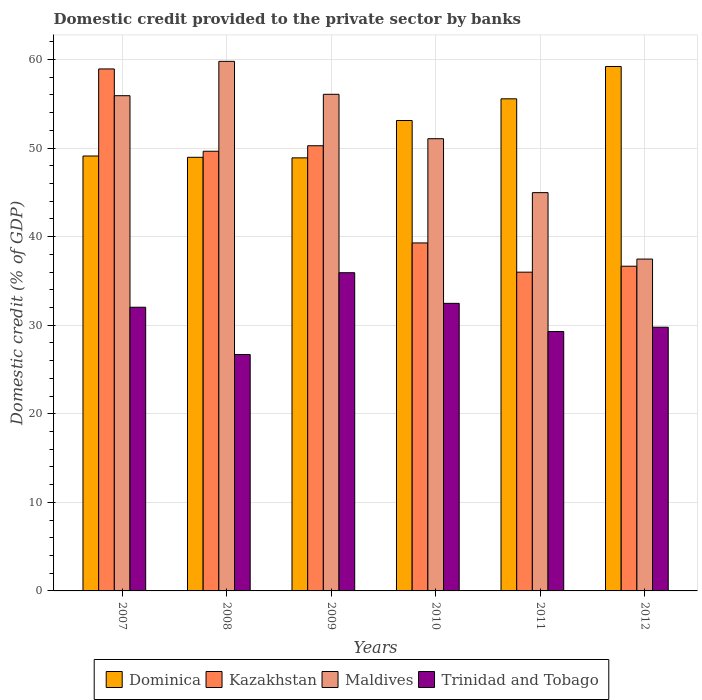How many different coloured bars are there?
Make the answer very short. 4. How many groups of bars are there?
Keep it short and to the point. 6. How many bars are there on the 4th tick from the right?
Your answer should be very brief. 4. What is the domestic credit provided to the private sector by banks in Maldives in 2010?
Provide a succinct answer. 51.06. Across all years, what is the maximum domestic credit provided to the private sector by banks in Trinidad and Tobago?
Make the answer very short. 35.93. Across all years, what is the minimum domestic credit provided to the private sector by banks in Maldives?
Keep it short and to the point. 37.47. What is the total domestic credit provided to the private sector by banks in Dominica in the graph?
Your response must be concise. 314.86. What is the difference between the domestic credit provided to the private sector by banks in Trinidad and Tobago in 2011 and that in 2012?
Offer a very short reply. -0.49. What is the difference between the domestic credit provided to the private sector by banks in Dominica in 2011 and the domestic credit provided to the private sector by banks in Trinidad and Tobago in 2012?
Give a very brief answer. 25.79. What is the average domestic credit provided to the private sector by banks in Kazakhstan per year?
Give a very brief answer. 45.13. In the year 2011, what is the difference between the domestic credit provided to the private sector by banks in Trinidad and Tobago and domestic credit provided to the private sector by banks in Maldives?
Provide a succinct answer. -15.68. In how many years, is the domestic credit provided to the private sector by banks in Trinidad and Tobago greater than 4 %?
Provide a succinct answer. 6. What is the ratio of the domestic credit provided to the private sector by banks in Kazakhstan in 2007 to that in 2008?
Your answer should be very brief. 1.19. Is the domestic credit provided to the private sector by banks in Dominica in 2010 less than that in 2012?
Your response must be concise. Yes. What is the difference between the highest and the second highest domestic credit provided to the private sector by banks in Trinidad and Tobago?
Keep it short and to the point. 3.46. What is the difference between the highest and the lowest domestic credit provided to the private sector by banks in Maldives?
Keep it short and to the point. 22.32. Is the sum of the domestic credit provided to the private sector by banks in Maldives in 2011 and 2012 greater than the maximum domestic credit provided to the private sector by banks in Kazakhstan across all years?
Keep it short and to the point. Yes. What does the 4th bar from the left in 2009 represents?
Ensure brevity in your answer.  Trinidad and Tobago. What does the 1st bar from the right in 2008 represents?
Your answer should be very brief. Trinidad and Tobago. How many bars are there?
Provide a succinct answer. 24. Are the values on the major ticks of Y-axis written in scientific E-notation?
Give a very brief answer. No. Where does the legend appear in the graph?
Ensure brevity in your answer.  Bottom center. How are the legend labels stacked?
Your response must be concise. Horizontal. What is the title of the graph?
Make the answer very short. Domestic credit provided to the private sector by banks. Does "Colombia" appear as one of the legend labels in the graph?
Your answer should be compact. No. What is the label or title of the X-axis?
Provide a succinct answer. Years. What is the label or title of the Y-axis?
Offer a very short reply. Domestic credit (% of GDP). What is the Domestic credit (% of GDP) in Dominica in 2007?
Ensure brevity in your answer.  49.11. What is the Domestic credit (% of GDP) in Kazakhstan in 2007?
Make the answer very short. 58.94. What is the Domestic credit (% of GDP) in Maldives in 2007?
Ensure brevity in your answer.  55.92. What is the Domestic credit (% of GDP) in Trinidad and Tobago in 2007?
Your answer should be very brief. 32.03. What is the Domestic credit (% of GDP) of Dominica in 2008?
Your answer should be very brief. 48.96. What is the Domestic credit (% of GDP) of Kazakhstan in 2008?
Offer a terse response. 49.64. What is the Domestic credit (% of GDP) in Maldives in 2008?
Your response must be concise. 59.8. What is the Domestic credit (% of GDP) of Trinidad and Tobago in 2008?
Offer a very short reply. 26.69. What is the Domestic credit (% of GDP) of Dominica in 2009?
Offer a terse response. 48.9. What is the Domestic credit (% of GDP) in Kazakhstan in 2009?
Provide a succinct answer. 50.27. What is the Domestic credit (% of GDP) of Maldives in 2009?
Keep it short and to the point. 56.07. What is the Domestic credit (% of GDP) in Trinidad and Tobago in 2009?
Offer a terse response. 35.93. What is the Domestic credit (% of GDP) in Dominica in 2010?
Your answer should be compact. 53.12. What is the Domestic credit (% of GDP) in Kazakhstan in 2010?
Provide a succinct answer. 39.29. What is the Domestic credit (% of GDP) of Maldives in 2010?
Provide a succinct answer. 51.06. What is the Domestic credit (% of GDP) of Trinidad and Tobago in 2010?
Give a very brief answer. 32.47. What is the Domestic credit (% of GDP) of Dominica in 2011?
Your response must be concise. 55.56. What is the Domestic credit (% of GDP) in Kazakhstan in 2011?
Ensure brevity in your answer.  35.99. What is the Domestic credit (% of GDP) of Maldives in 2011?
Your answer should be compact. 44.97. What is the Domestic credit (% of GDP) of Trinidad and Tobago in 2011?
Your response must be concise. 29.29. What is the Domestic credit (% of GDP) of Dominica in 2012?
Offer a very short reply. 59.21. What is the Domestic credit (% of GDP) of Kazakhstan in 2012?
Offer a terse response. 36.66. What is the Domestic credit (% of GDP) of Maldives in 2012?
Make the answer very short. 37.47. What is the Domestic credit (% of GDP) of Trinidad and Tobago in 2012?
Make the answer very short. 29.78. Across all years, what is the maximum Domestic credit (% of GDP) in Dominica?
Provide a short and direct response. 59.21. Across all years, what is the maximum Domestic credit (% of GDP) of Kazakhstan?
Make the answer very short. 58.94. Across all years, what is the maximum Domestic credit (% of GDP) of Maldives?
Your answer should be compact. 59.8. Across all years, what is the maximum Domestic credit (% of GDP) in Trinidad and Tobago?
Keep it short and to the point. 35.93. Across all years, what is the minimum Domestic credit (% of GDP) of Dominica?
Provide a succinct answer. 48.9. Across all years, what is the minimum Domestic credit (% of GDP) of Kazakhstan?
Give a very brief answer. 35.99. Across all years, what is the minimum Domestic credit (% of GDP) in Maldives?
Ensure brevity in your answer.  37.47. Across all years, what is the minimum Domestic credit (% of GDP) in Trinidad and Tobago?
Your answer should be compact. 26.69. What is the total Domestic credit (% of GDP) in Dominica in the graph?
Offer a terse response. 314.86. What is the total Domestic credit (% of GDP) of Kazakhstan in the graph?
Your response must be concise. 270.8. What is the total Domestic credit (% of GDP) in Maldives in the graph?
Your response must be concise. 305.29. What is the total Domestic credit (% of GDP) of Trinidad and Tobago in the graph?
Make the answer very short. 186.19. What is the difference between the Domestic credit (% of GDP) in Dominica in 2007 and that in 2008?
Provide a succinct answer. 0.15. What is the difference between the Domestic credit (% of GDP) of Kazakhstan in 2007 and that in 2008?
Offer a very short reply. 9.29. What is the difference between the Domestic credit (% of GDP) in Maldives in 2007 and that in 2008?
Make the answer very short. -3.88. What is the difference between the Domestic credit (% of GDP) of Trinidad and Tobago in 2007 and that in 2008?
Offer a very short reply. 5.34. What is the difference between the Domestic credit (% of GDP) of Dominica in 2007 and that in 2009?
Your answer should be compact. 0.21. What is the difference between the Domestic credit (% of GDP) of Kazakhstan in 2007 and that in 2009?
Offer a terse response. 8.67. What is the difference between the Domestic credit (% of GDP) in Maldives in 2007 and that in 2009?
Offer a very short reply. -0.16. What is the difference between the Domestic credit (% of GDP) in Trinidad and Tobago in 2007 and that in 2009?
Give a very brief answer. -3.9. What is the difference between the Domestic credit (% of GDP) of Dominica in 2007 and that in 2010?
Ensure brevity in your answer.  -4.01. What is the difference between the Domestic credit (% of GDP) in Kazakhstan in 2007 and that in 2010?
Your response must be concise. 19.65. What is the difference between the Domestic credit (% of GDP) in Maldives in 2007 and that in 2010?
Your answer should be compact. 4.86. What is the difference between the Domestic credit (% of GDP) of Trinidad and Tobago in 2007 and that in 2010?
Offer a terse response. -0.44. What is the difference between the Domestic credit (% of GDP) in Dominica in 2007 and that in 2011?
Offer a terse response. -6.46. What is the difference between the Domestic credit (% of GDP) of Kazakhstan in 2007 and that in 2011?
Keep it short and to the point. 22.95. What is the difference between the Domestic credit (% of GDP) in Maldives in 2007 and that in 2011?
Provide a short and direct response. 10.95. What is the difference between the Domestic credit (% of GDP) in Trinidad and Tobago in 2007 and that in 2011?
Keep it short and to the point. 2.74. What is the difference between the Domestic credit (% of GDP) of Dominica in 2007 and that in 2012?
Offer a terse response. -10.11. What is the difference between the Domestic credit (% of GDP) of Kazakhstan in 2007 and that in 2012?
Your answer should be very brief. 22.27. What is the difference between the Domestic credit (% of GDP) in Maldives in 2007 and that in 2012?
Your response must be concise. 18.45. What is the difference between the Domestic credit (% of GDP) of Trinidad and Tobago in 2007 and that in 2012?
Ensure brevity in your answer.  2.26. What is the difference between the Domestic credit (% of GDP) in Dominica in 2008 and that in 2009?
Your answer should be very brief. 0.06. What is the difference between the Domestic credit (% of GDP) of Kazakhstan in 2008 and that in 2009?
Ensure brevity in your answer.  -0.62. What is the difference between the Domestic credit (% of GDP) of Maldives in 2008 and that in 2009?
Provide a succinct answer. 3.72. What is the difference between the Domestic credit (% of GDP) of Trinidad and Tobago in 2008 and that in 2009?
Offer a very short reply. -9.24. What is the difference between the Domestic credit (% of GDP) of Dominica in 2008 and that in 2010?
Your answer should be very brief. -4.15. What is the difference between the Domestic credit (% of GDP) of Kazakhstan in 2008 and that in 2010?
Provide a short and direct response. 10.35. What is the difference between the Domestic credit (% of GDP) in Maldives in 2008 and that in 2010?
Offer a terse response. 8.73. What is the difference between the Domestic credit (% of GDP) in Trinidad and Tobago in 2008 and that in 2010?
Your response must be concise. -5.78. What is the difference between the Domestic credit (% of GDP) of Dominica in 2008 and that in 2011?
Keep it short and to the point. -6.6. What is the difference between the Domestic credit (% of GDP) in Kazakhstan in 2008 and that in 2011?
Keep it short and to the point. 13.65. What is the difference between the Domestic credit (% of GDP) in Maldives in 2008 and that in 2011?
Your answer should be compact. 14.82. What is the difference between the Domestic credit (% of GDP) of Trinidad and Tobago in 2008 and that in 2011?
Give a very brief answer. -2.6. What is the difference between the Domestic credit (% of GDP) of Dominica in 2008 and that in 2012?
Provide a succinct answer. -10.25. What is the difference between the Domestic credit (% of GDP) in Kazakhstan in 2008 and that in 2012?
Provide a succinct answer. 12.98. What is the difference between the Domestic credit (% of GDP) in Maldives in 2008 and that in 2012?
Your answer should be very brief. 22.32. What is the difference between the Domestic credit (% of GDP) of Trinidad and Tobago in 2008 and that in 2012?
Provide a succinct answer. -3.08. What is the difference between the Domestic credit (% of GDP) of Dominica in 2009 and that in 2010?
Provide a short and direct response. -4.22. What is the difference between the Domestic credit (% of GDP) of Kazakhstan in 2009 and that in 2010?
Your answer should be very brief. 10.97. What is the difference between the Domestic credit (% of GDP) in Maldives in 2009 and that in 2010?
Offer a very short reply. 5.01. What is the difference between the Domestic credit (% of GDP) in Trinidad and Tobago in 2009 and that in 2010?
Offer a very short reply. 3.46. What is the difference between the Domestic credit (% of GDP) in Dominica in 2009 and that in 2011?
Provide a succinct answer. -6.67. What is the difference between the Domestic credit (% of GDP) in Kazakhstan in 2009 and that in 2011?
Your response must be concise. 14.27. What is the difference between the Domestic credit (% of GDP) in Maldives in 2009 and that in 2011?
Keep it short and to the point. 11.1. What is the difference between the Domestic credit (% of GDP) in Trinidad and Tobago in 2009 and that in 2011?
Offer a terse response. 6.64. What is the difference between the Domestic credit (% of GDP) of Dominica in 2009 and that in 2012?
Give a very brief answer. -10.32. What is the difference between the Domestic credit (% of GDP) of Kazakhstan in 2009 and that in 2012?
Ensure brevity in your answer.  13.6. What is the difference between the Domestic credit (% of GDP) of Maldives in 2009 and that in 2012?
Offer a very short reply. 18.6. What is the difference between the Domestic credit (% of GDP) in Trinidad and Tobago in 2009 and that in 2012?
Offer a very short reply. 6.15. What is the difference between the Domestic credit (% of GDP) in Dominica in 2010 and that in 2011?
Your answer should be compact. -2.45. What is the difference between the Domestic credit (% of GDP) in Kazakhstan in 2010 and that in 2011?
Make the answer very short. 3.3. What is the difference between the Domestic credit (% of GDP) in Maldives in 2010 and that in 2011?
Offer a very short reply. 6.09. What is the difference between the Domestic credit (% of GDP) in Trinidad and Tobago in 2010 and that in 2011?
Offer a very short reply. 3.18. What is the difference between the Domestic credit (% of GDP) of Dominica in 2010 and that in 2012?
Provide a short and direct response. -6.1. What is the difference between the Domestic credit (% of GDP) of Kazakhstan in 2010 and that in 2012?
Offer a very short reply. 2.63. What is the difference between the Domestic credit (% of GDP) of Maldives in 2010 and that in 2012?
Your response must be concise. 13.59. What is the difference between the Domestic credit (% of GDP) in Trinidad and Tobago in 2010 and that in 2012?
Keep it short and to the point. 2.7. What is the difference between the Domestic credit (% of GDP) of Dominica in 2011 and that in 2012?
Give a very brief answer. -3.65. What is the difference between the Domestic credit (% of GDP) in Kazakhstan in 2011 and that in 2012?
Keep it short and to the point. -0.67. What is the difference between the Domestic credit (% of GDP) of Maldives in 2011 and that in 2012?
Offer a very short reply. 7.5. What is the difference between the Domestic credit (% of GDP) in Trinidad and Tobago in 2011 and that in 2012?
Provide a succinct answer. -0.49. What is the difference between the Domestic credit (% of GDP) of Dominica in 2007 and the Domestic credit (% of GDP) of Kazakhstan in 2008?
Your response must be concise. -0.54. What is the difference between the Domestic credit (% of GDP) in Dominica in 2007 and the Domestic credit (% of GDP) in Maldives in 2008?
Make the answer very short. -10.69. What is the difference between the Domestic credit (% of GDP) in Dominica in 2007 and the Domestic credit (% of GDP) in Trinidad and Tobago in 2008?
Make the answer very short. 22.42. What is the difference between the Domestic credit (% of GDP) in Kazakhstan in 2007 and the Domestic credit (% of GDP) in Maldives in 2008?
Offer a terse response. -0.86. What is the difference between the Domestic credit (% of GDP) in Kazakhstan in 2007 and the Domestic credit (% of GDP) in Trinidad and Tobago in 2008?
Provide a short and direct response. 32.25. What is the difference between the Domestic credit (% of GDP) of Maldives in 2007 and the Domestic credit (% of GDP) of Trinidad and Tobago in 2008?
Your answer should be very brief. 29.22. What is the difference between the Domestic credit (% of GDP) in Dominica in 2007 and the Domestic credit (% of GDP) in Kazakhstan in 2009?
Make the answer very short. -1.16. What is the difference between the Domestic credit (% of GDP) of Dominica in 2007 and the Domestic credit (% of GDP) of Maldives in 2009?
Give a very brief answer. -6.97. What is the difference between the Domestic credit (% of GDP) in Dominica in 2007 and the Domestic credit (% of GDP) in Trinidad and Tobago in 2009?
Your response must be concise. 13.18. What is the difference between the Domestic credit (% of GDP) in Kazakhstan in 2007 and the Domestic credit (% of GDP) in Maldives in 2009?
Your response must be concise. 2.86. What is the difference between the Domestic credit (% of GDP) of Kazakhstan in 2007 and the Domestic credit (% of GDP) of Trinidad and Tobago in 2009?
Keep it short and to the point. 23.01. What is the difference between the Domestic credit (% of GDP) in Maldives in 2007 and the Domestic credit (% of GDP) in Trinidad and Tobago in 2009?
Provide a succinct answer. 19.99. What is the difference between the Domestic credit (% of GDP) in Dominica in 2007 and the Domestic credit (% of GDP) in Kazakhstan in 2010?
Ensure brevity in your answer.  9.82. What is the difference between the Domestic credit (% of GDP) of Dominica in 2007 and the Domestic credit (% of GDP) of Maldives in 2010?
Keep it short and to the point. -1.95. What is the difference between the Domestic credit (% of GDP) in Dominica in 2007 and the Domestic credit (% of GDP) in Trinidad and Tobago in 2010?
Offer a very short reply. 16.64. What is the difference between the Domestic credit (% of GDP) in Kazakhstan in 2007 and the Domestic credit (% of GDP) in Maldives in 2010?
Ensure brevity in your answer.  7.88. What is the difference between the Domestic credit (% of GDP) in Kazakhstan in 2007 and the Domestic credit (% of GDP) in Trinidad and Tobago in 2010?
Make the answer very short. 26.47. What is the difference between the Domestic credit (% of GDP) in Maldives in 2007 and the Domestic credit (% of GDP) in Trinidad and Tobago in 2010?
Your answer should be compact. 23.45. What is the difference between the Domestic credit (% of GDP) of Dominica in 2007 and the Domestic credit (% of GDP) of Kazakhstan in 2011?
Give a very brief answer. 13.12. What is the difference between the Domestic credit (% of GDP) in Dominica in 2007 and the Domestic credit (% of GDP) in Maldives in 2011?
Your response must be concise. 4.14. What is the difference between the Domestic credit (% of GDP) in Dominica in 2007 and the Domestic credit (% of GDP) in Trinidad and Tobago in 2011?
Ensure brevity in your answer.  19.82. What is the difference between the Domestic credit (% of GDP) in Kazakhstan in 2007 and the Domestic credit (% of GDP) in Maldives in 2011?
Your answer should be compact. 13.97. What is the difference between the Domestic credit (% of GDP) of Kazakhstan in 2007 and the Domestic credit (% of GDP) of Trinidad and Tobago in 2011?
Make the answer very short. 29.65. What is the difference between the Domestic credit (% of GDP) of Maldives in 2007 and the Domestic credit (% of GDP) of Trinidad and Tobago in 2011?
Your answer should be compact. 26.63. What is the difference between the Domestic credit (% of GDP) of Dominica in 2007 and the Domestic credit (% of GDP) of Kazakhstan in 2012?
Make the answer very short. 12.44. What is the difference between the Domestic credit (% of GDP) in Dominica in 2007 and the Domestic credit (% of GDP) in Maldives in 2012?
Keep it short and to the point. 11.64. What is the difference between the Domestic credit (% of GDP) of Dominica in 2007 and the Domestic credit (% of GDP) of Trinidad and Tobago in 2012?
Your answer should be compact. 19.33. What is the difference between the Domestic credit (% of GDP) of Kazakhstan in 2007 and the Domestic credit (% of GDP) of Maldives in 2012?
Your response must be concise. 21.47. What is the difference between the Domestic credit (% of GDP) of Kazakhstan in 2007 and the Domestic credit (% of GDP) of Trinidad and Tobago in 2012?
Your answer should be very brief. 29.16. What is the difference between the Domestic credit (% of GDP) in Maldives in 2007 and the Domestic credit (% of GDP) in Trinidad and Tobago in 2012?
Make the answer very short. 26.14. What is the difference between the Domestic credit (% of GDP) in Dominica in 2008 and the Domestic credit (% of GDP) in Kazakhstan in 2009?
Provide a succinct answer. -1.3. What is the difference between the Domestic credit (% of GDP) of Dominica in 2008 and the Domestic credit (% of GDP) of Maldives in 2009?
Offer a terse response. -7.11. What is the difference between the Domestic credit (% of GDP) in Dominica in 2008 and the Domestic credit (% of GDP) in Trinidad and Tobago in 2009?
Your response must be concise. 13.03. What is the difference between the Domestic credit (% of GDP) in Kazakhstan in 2008 and the Domestic credit (% of GDP) in Maldives in 2009?
Your answer should be very brief. -6.43. What is the difference between the Domestic credit (% of GDP) in Kazakhstan in 2008 and the Domestic credit (% of GDP) in Trinidad and Tobago in 2009?
Keep it short and to the point. 13.72. What is the difference between the Domestic credit (% of GDP) of Maldives in 2008 and the Domestic credit (% of GDP) of Trinidad and Tobago in 2009?
Offer a very short reply. 23.87. What is the difference between the Domestic credit (% of GDP) in Dominica in 2008 and the Domestic credit (% of GDP) in Kazakhstan in 2010?
Your answer should be compact. 9.67. What is the difference between the Domestic credit (% of GDP) in Dominica in 2008 and the Domestic credit (% of GDP) in Maldives in 2010?
Your answer should be compact. -2.1. What is the difference between the Domestic credit (% of GDP) in Dominica in 2008 and the Domestic credit (% of GDP) in Trinidad and Tobago in 2010?
Offer a very short reply. 16.49. What is the difference between the Domestic credit (% of GDP) in Kazakhstan in 2008 and the Domestic credit (% of GDP) in Maldives in 2010?
Make the answer very short. -1.42. What is the difference between the Domestic credit (% of GDP) in Kazakhstan in 2008 and the Domestic credit (% of GDP) in Trinidad and Tobago in 2010?
Offer a terse response. 17.17. What is the difference between the Domestic credit (% of GDP) of Maldives in 2008 and the Domestic credit (% of GDP) of Trinidad and Tobago in 2010?
Offer a very short reply. 27.32. What is the difference between the Domestic credit (% of GDP) in Dominica in 2008 and the Domestic credit (% of GDP) in Kazakhstan in 2011?
Keep it short and to the point. 12.97. What is the difference between the Domestic credit (% of GDP) in Dominica in 2008 and the Domestic credit (% of GDP) in Maldives in 2011?
Provide a short and direct response. 3.99. What is the difference between the Domestic credit (% of GDP) in Dominica in 2008 and the Domestic credit (% of GDP) in Trinidad and Tobago in 2011?
Your answer should be very brief. 19.67. What is the difference between the Domestic credit (% of GDP) of Kazakhstan in 2008 and the Domestic credit (% of GDP) of Maldives in 2011?
Offer a very short reply. 4.67. What is the difference between the Domestic credit (% of GDP) of Kazakhstan in 2008 and the Domestic credit (% of GDP) of Trinidad and Tobago in 2011?
Provide a short and direct response. 20.35. What is the difference between the Domestic credit (% of GDP) in Maldives in 2008 and the Domestic credit (% of GDP) in Trinidad and Tobago in 2011?
Give a very brief answer. 30.51. What is the difference between the Domestic credit (% of GDP) of Dominica in 2008 and the Domestic credit (% of GDP) of Kazakhstan in 2012?
Your response must be concise. 12.3. What is the difference between the Domestic credit (% of GDP) of Dominica in 2008 and the Domestic credit (% of GDP) of Maldives in 2012?
Provide a short and direct response. 11.49. What is the difference between the Domestic credit (% of GDP) of Dominica in 2008 and the Domestic credit (% of GDP) of Trinidad and Tobago in 2012?
Make the answer very short. 19.18. What is the difference between the Domestic credit (% of GDP) of Kazakhstan in 2008 and the Domestic credit (% of GDP) of Maldives in 2012?
Provide a succinct answer. 12.17. What is the difference between the Domestic credit (% of GDP) in Kazakhstan in 2008 and the Domestic credit (% of GDP) in Trinidad and Tobago in 2012?
Give a very brief answer. 19.87. What is the difference between the Domestic credit (% of GDP) of Maldives in 2008 and the Domestic credit (% of GDP) of Trinidad and Tobago in 2012?
Provide a short and direct response. 30.02. What is the difference between the Domestic credit (% of GDP) of Dominica in 2009 and the Domestic credit (% of GDP) of Kazakhstan in 2010?
Ensure brevity in your answer.  9.6. What is the difference between the Domestic credit (% of GDP) in Dominica in 2009 and the Domestic credit (% of GDP) in Maldives in 2010?
Ensure brevity in your answer.  -2.16. What is the difference between the Domestic credit (% of GDP) of Dominica in 2009 and the Domestic credit (% of GDP) of Trinidad and Tobago in 2010?
Offer a very short reply. 16.43. What is the difference between the Domestic credit (% of GDP) in Kazakhstan in 2009 and the Domestic credit (% of GDP) in Maldives in 2010?
Your answer should be very brief. -0.79. What is the difference between the Domestic credit (% of GDP) in Kazakhstan in 2009 and the Domestic credit (% of GDP) in Trinidad and Tobago in 2010?
Your response must be concise. 17.79. What is the difference between the Domestic credit (% of GDP) in Maldives in 2009 and the Domestic credit (% of GDP) in Trinidad and Tobago in 2010?
Your answer should be very brief. 23.6. What is the difference between the Domestic credit (% of GDP) of Dominica in 2009 and the Domestic credit (% of GDP) of Kazakhstan in 2011?
Give a very brief answer. 12.91. What is the difference between the Domestic credit (% of GDP) in Dominica in 2009 and the Domestic credit (% of GDP) in Maldives in 2011?
Provide a short and direct response. 3.93. What is the difference between the Domestic credit (% of GDP) in Dominica in 2009 and the Domestic credit (% of GDP) in Trinidad and Tobago in 2011?
Your answer should be compact. 19.61. What is the difference between the Domestic credit (% of GDP) in Kazakhstan in 2009 and the Domestic credit (% of GDP) in Maldives in 2011?
Give a very brief answer. 5.29. What is the difference between the Domestic credit (% of GDP) in Kazakhstan in 2009 and the Domestic credit (% of GDP) in Trinidad and Tobago in 2011?
Offer a terse response. 20.98. What is the difference between the Domestic credit (% of GDP) in Maldives in 2009 and the Domestic credit (% of GDP) in Trinidad and Tobago in 2011?
Your answer should be compact. 26.79. What is the difference between the Domestic credit (% of GDP) of Dominica in 2009 and the Domestic credit (% of GDP) of Kazakhstan in 2012?
Provide a succinct answer. 12.23. What is the difference between the Domestic credit (% of GDP) of Dominica in 2009 and the Domestic credit (% of GDP) of Maldives in 2012?
Your answer should be compact. 11.43. What is the difference between the Domestic credit (% of GDP) of Dominica in 2009 and the Domestic credit (% of GDP) of Trinidad and Tobago in 2012?
Make the answer very short. 19.12. What is the difference between the Domestic credit (% of GDP) in Kazakhstan in 2009 and the Domestic credit (% of GDP) in Maldives in 2012?
Offer a terse response. 12.8. What is the difference between the Domestic credit (% of GDP) of Kazakhstan in 2009 and the Domestic credit (% of GDP) of Trinidad and Tobago in 2012?
Your response must be concise. 20.49. What is the difference between the Domestic credit (% of GDP) in Maldives in 2009 and the Domestic credit (% of GDP) in Trinidad and Tobago in 2012?
Your answer should be compact. 26.3. What is the difference between the Domestic credit (% of GDP) of Dominica in 2010 and the Domestic credit (% of GDP) of Kazakhstan in 2011?
Provide a short and direct response. 17.12. What is the difference between the Domestic credit (% of GDP) of Dominica in 2010 and the Domestic credit (% of GDP) of Maldives in 2011?
Your answer should be very brief. 8.14. What is the difference between the Domestic credit (% of GDP) of Dominica in 2010 and the Domestic credit (% of GDP) of Trinidad and Tobago in 2011?
Make the answer very short. 23.83. What is the difference between the Domestic credit (% of GDP) in Kazakhstan in 2010 and the Domestic credit (% of GDP) in Maldives in 2011?
Your answer should be very brief. -5.68. What is the difference between the Domestic credit (% of GDP) of Kazakhstan in 2010 and the Domestic credit (% of GDP) of Trinidad and Tobago in 2011?
Your answer should be very brief. 10. What is the difference between the Domestic credit (% of GDP) in Maldives in 2010 and the Domestic credit (% of GDP) in Trinidad and Tobago in 2011?
Give a very brief answer. 21.77. What is the difference between the Domestic credit (% of GDP) in Dominica in 2010 and the Domestic credit (% of GDP) in Kazakhstan in 2012?
Your answer should be compact. 16.45. What is the difference between the Domestic credit (% of GDP) in Dominica in 2010 and the Domestic credit (% of GDP) in Maldives in 2012?
Provide a succinct answer. 15.65. What is the difference between the Domestic credit (% of GDP) in Dominica in 2010 and the Domestic credit (% of GDP) in Trinidad and Tobago in 2012?
Ensure brevity in your answer.  23.34. What is the difference between the Domestic credit (% of GDP) of Kazakhstan in 2010 and the Domestic credit (% of GDP) of Maldives in 2012?
Your answer should be compact. 1.82. What is the difference between the Domestic credit (% of GDP) of Kazakhstan in 2010 and the Domestic credit (% of GDP) of Trinidad and Tobago in 2012?
Offer a very short reply. 9.52. What is the difference between the Domestic credit (% of GDP) of Maldives in 2010 and the Domestic credit (% of GDP) of Trinidad and Tobago in 2012?
Provide a succinct answer. 21.28. What is the difference between the Domestic credit (% of GDP) in Dominica in 2011 and the Domestic credit (% of GDP) in Kazakhstan in 2012?
Give a very brief answer. 18.9. What is the difference between the Domestic credit (% of GDP) in Dominica in 2011 and the Domestic credit (% of GDP) in Maldives in 2012?
Keep it short and to the point. 18.09. What is the difference between the Domestic credit (% of GDP) of Dominica in 2011 and the Domestic credit (% of GDP) of Trinidad and Tobago in 2012?
Your response must be concise. 25.79. What is the difference between the Domestic credit (% of GDP) of Kazakhstan in 2011 and the Domestic credit (% of GDP) of Maldives in 2012?
Offer a terse response. -1.48. What is the difference between the Domestic credit (% of GDP) of Kazakhstan in 2011 and the Domestic credit (% of GDP) of Trinidad and Tobago in 2012?
Ensure brevity in your answer.  6.22. What is the difference between the Domestic credit (% of GDP) of Maldives in 2011 and the Domestic credit (% of GDP) of Trinidad and Tobago in 2012?
Make the answer very short. 15.2. What is the average Domestic credit (% of GDP) in Dominica per year?
Offer a very short reply. 52.48. What is the average Domestic credit (% of GDP) in Kazakhstan per year?
Make the answer very short. 45.13. What is the average Domestic credit (% of GDP) of Maldives per year?
Provide a succinct answer. 50.88. What is the average Domestic credit (% of GDP) of Trinidad and Tobago per year?
Offer a terse response. 31.03. In the year 2007, what is the difference between the Domestic credit (% of GDP) of Dominica and Domestic credit (% of GDP) of Kazakhstan?
Give a very brief answer. -9.83. In the year 2007, what is the difference between the Domestic credit (% of GDP) in Dominica and Domestic credit (% of GDP) in Maldives?
Provide a succinct answer. -6.81. In the year 2007, what is the difference between the Domestic credit (% of GDP) in Dominica and Domestic credit (% of GDP) in Trinidad and Tobago?
Give a very brief answer. 17.08. In the year 2007, what is the difference between the Domestic credit (% of GDP) of Kazakhstan and Domestic credit (% of GDP) of Maldives?
Make the answer very short. 3.02. In the year 2007, what is the difference between the Domestic credit (% of GDP) of Kazakhstan and Domestic credit (% of GDP) of Trinidad and Tobago?
Make the answer very short. 26.91. In the year 2007, what is the difference between the Domestic credit (% of GDP) in Maldives and Domestic credit (% of GDP) in Trinidad and Tobago?
Your answer should be very brief. 23.89. In the year 2008, what is the difference between the Domestic credit (% of GDP) in Dominica and Domestic credit (% of GDP) in Kazakhstan?
Give a very brief answer. -0.68. In the year 2008, what is the difference between the Domestic credit (% of GDP) in Dominica and Domestic credit (% of GDP) in Maldives?
Ensure brevity in your answer.  -10.83. In the year 2008, what is the difference between the Domestic credit (% of GDP) of Dominica and Domestic credit (% of GDP) of Trinidad and Tobago?
Your answer should be compact. 22.27. In the year 2008, what is the difference between the Domestic credit (% of GDP) in Kazakhstan and Domestic credit (% of GDP) in Maldives?
Make the answer very short. -10.15. In the year 2008, what is the difference between the Domestic credit (% of GDP) in Kazakhstan and Domestic credit (% of GDP) in Trinidad and Tobago?
Give a very brief answer. 22.95. In the year 2008, what is the difference between the Domestic credit (% of GDP) of Maldives and Domestic credit (% of GDP) of Trinidad and Tobago?
Give a very brief answer. 33.1. In the year 2009, what is the difference between the Domestic credit (% of GDP) in Dominica and Domestic credit (% of GDP) in Kazakhstan?
Offer a terse response. -1.37. In the year 2009, what is the difference between the Domestic credit (% of GDP) of Dominica and Domestic credit (% of GDP) of Maldives?
Your response must be concise. -7.18. In the year 2009, what is the difference between the Domestic credit (% of GDP) of Dominica and Domestic credit (% of GDP) of Trinidad and Tobago?
Offer a very short reply. 12.97. In the year 2009, what is the difference between the Domestic credit (% of GDP) of Kazakhstan and Domestic credit (% of GDP) of Maldives?
Keep it short and to the point. -5.81. In the year 2009, what is the difference between the Domestic credit (% of GDP) in Kazakhstan and Domestic credit (% of GDP) in Trinidad and Tobago?
Offer a very short reply. 14.34. In the year 2009, what is the difference between the Domestic credit (% of GDP) of Maldives and Domestic credit (% of GDP) of Trinidad and Tobago?
Your response must be concise. 20.15. In the year 2010, what is the difference between the Domestic credit (% of GDP) in Dominica and Domestic credit (% of GDP) in Kazakhstan?
Ensure brevity in your answer.  13.82. In the year 2010, what is the difference between the Domestic credit (% of GDP) of Dominica and Domestic credit (% of GDP) of Maldives?
Keep it short and to the point. 2.06. In the year 2010, what is the difference between the Domestic credit (% of GDP) in Dominica and Domestic credit (% of GDP) in Trinidad and Tobago?
Give a very brief answer. 20.64. In the year 2010, what is the difference between the Domestic credit (% of GDP) in Kazakhstan and Domestic credit (% of GDP) in Maldives?
Offer a terse response. -11.77. In the year 2010, what is the difference between the Domestic credit (% of GDP) in Kazakhstan and Domestic credit (% of GDP) in Trinidad and Tobago?
Keep it short and to the point. 6.82. In the year 2010, what is the difference between the Domestic credit (% of GDP) of Maldives and Domestic credit (% of GDP) of Trinidad and Tobago?
Offer a very short reply. 18.59. In the year 2011, what is the difference between the Domestic credit (% of GDP) of Dominica and Domestic credit (% of GDP) of Kazakhstan?
Your response must be concise. 19.57. In the year 2011, what is the difference between the Domestic credit (% of GDP) in Dominica and Domestic credit (% of GDP) in Maldives?
Your response must be concise. 10.59. In the year 2011, what is the difference between the Domestic credit (% of GDP) in Dominica and Domestic credit (% of GDP) in Trinidad and Tobago?
Give a very brief answer. 26.27. In the year 2011, what is the difference between the Domestic credit (% of GDP) of Kazakhstan and Domestic credit (% of GDP) of Maldives?
Your answer should be very brief. -8.98. In the year 2011, what is the difference between the Domestic credit (% of GDP) in Kazakhstan and Domestic credit (% of GDP) in Trinidad and Tobago?
Give a very brief answer. 6.7. In the year 2011, what is the difference between the Domestic credit (% of GDP) of Maldives and Domestic credit (% of GDP) of Trinidad and Tobago?
Your answer should be compact. 15.68. In the year 2012, what is the difference between the Domestic credit (% of GDP) in Dominica and Domestic credit (% of GDP) in Kazakhstan?
Ensure brevity in your answer.  22.55. In the year 2012, what is the difference between the Domestic credit (% of GDP) of Dominica and Domestic credit (% of GDP) of Maldives?
Provide a short and direct response. 21.74. In the year 2012, what is the difference between the Domestic credit (% of GDP) in Dominica and Domestic credit (% of GDP) in Trinidad and Tobago?
Make the answer very short. 29.44. In the year 2012, what is the difference between the Domestic credit (% of GDP) of Kazakhstan and Domestic credit (% of GDP) of Maldives?
Make the answer very short. -0.81. In the year 2012, what is the difference between the Domestic credit (% of GDP) in Kazakhstan and Domestic credit (% of GDP) in Trinidad and Tobago?
Offer a terse response. 6.89. In the year 2012, what is the difference between the Domestic credit (% of GDP) in Maldives and Domestic credit (% of GDP) in Trinidad and Tobago?
Give a very brief answer. 7.69. What is the ratio of the Domestic credit (% of GDP) of Dominica in 2007 to that in 2008?
Provide a succinct answer. 1. What is the ratio of the Domestic credit (% of GDP) in Kazakhstan in 2007 to that in 2008?
Keep it short and to the point. 1.19. What is the ratio of the Domestic credit (% of GDP) in Maldives in 2007 to that in 2008?
Offer a very short reply. 0.94. What is the ratio of the Domestic credit (% of GDP) of Kazakhstan in 2007 to that in 2009?
Give a very brief answer. 1.17. What is the ratio of the Domestic credit (% of GDP) of Trinidad and Tobago in 2007 to that in 2009?
Your answer should be very brief. 0.89. What is the ratio of the Domestic credit (% of GDP) in Dominica in 2007 to that in 2010?
Your answer should be compact. 0.92. What is the ratio of the Domestic credit (% of GDP) in Maldives in 2007 to that in 2010?
Your answer should be compact. 1.1. What is the ratio of the Domestic credit (% of GDP) in Trinidad and Tobago in 2007 to that in 2010?
Ensure brevity in your answer.  0.99. What is the ratio of the Domestic credit (% of GDP) of Dominica in 2007 to that in 2011?
Provide a short and direct response. 0.88. What is the ratio of the Domestic credit (% of GDP) of Kazakhstan in 2007 to that in 2011?
Make the answer very short. 1.64. What is the ratio of the Domestic credit (% of GDP) in Maldives in 2007 to that in 2011?
Give a very brief answer. 1.24. What is the ratio of the Domestic credit (% of GDP) in Trinidad and Tobago in 2007 to that in 2011?
Offer a very short reply. 1.09. What is the ratio of the Domestic credit (% of GDP) of Dominica in 2007 to that in 2012?
Ensure brevity in your answer.  0.83. What is the ratio of the Domestic credit (% of GDP) of Kazakhstan in 2007 to that in 2012?
Your answer should be very brief. 1.61. What is the ratio of the Domestic credit (% of GDP) in Maldives in 2007 to that in 2012?
Offer a terse response. 1.49. What is the ratio of the Domestic credit (% of GDP) in Trinidad and Tobago in 2007 to that in 2012?
Provide a succinct answer. 1.08. What is the ratio of the Domestic credit (% of GDP) in Dominica in 2008 to that in 2009?
Ensure brevity in your answer.  1. What is the ratio of the Domestic credit (% of GDP) in Kazakhstan in 2008 to that in 2009?
Provide a short and direct response. 0.99. What is the ratio of the Domestic credit (% of GDP) of Maldives in 2008 to that in 2009?
Your response must be concise. 1.07. What is the ratio of the Domestic credit (% of GDP) in Trinidad and Tobago in 2008 to that in 2009?
Provide a succinct answer. 0.74. What is the ratio of the Domestic credit (% of GDP) in Dominica in 2008 to that in 2010?
Your response must be concise. 0.92. What is the ratio of the Domestic credit (% of GDP) in Kazakhstan in 2008 to that in 2010?
Your answer should be very brief. 1.26. What is the ratio of the Domestic credit (% of GDP) in Maldives in 2008 to that in 2010?
Offer a very short reply. 1.17. What is the ratio of the Domestic credit (% of GDP) of Trinidad and Tobago in 2008 to that in 2010?
Your response must be concise. 0.82. What is the ratio of the Domestic credit (% of GDP) in Dominica in 2008 to that in 2011?
Your response must be concise. 0.88. What is the ratio of the Domestic credit (% of GDP) of Kazakhstan in 2008 to that in 2011?
Your answer should be very brief. 1.38. What is the ratio of the Domestic credit (% of GDP) in Maldives in 2008 to that in 2011?
Provide a succinct answer. 1.33. What is the ratio of the Domestic credit (% of GDP) in Trinidad and Tobago in 2008 to that in 2011?
Your answer should be compact. 0.91. What is the ratio of the Domestic credit (% of GDP) of Dominica in 2008 to that in 2012?
Keep it short and to the point. 0.83. What is the ratio of the Domestic credit (% of GDP) in Kazakhstan in 2008 to that in 2012?
Offer a terse response. 1.35. What is the ratio of the Domestic credit (% of GDP) of Maldives in 2008 to that in 2012?
Offer a terse response. 1.6. What is the ratio of the Domestic credit (% of GDP) of Trinidad and Tobago in 2008 to that in 2012?
Keep it short and to the point. 0.9. What is the ratio of the Domestic credit (% of GDP) in Dominica in 2009 to that in 2010?
Offer a very short reply. 0.92. What is the ratio of the Domestic credit (% of GDP) of Kazakhstan in 2009 to that in 2010?
Offer a terse response. 1.28. What is the ratio of the Domestic credit (% of GDP) in Maldives in 2009 to that in 2010?
Give a very brief answer. 1.1. What is the ratio of the Domestic credit (% of GDP) in Trinidad and Tobago in 2009 to that in 2010?
Provide a succinct answer. 1.11. What is the ratio of the Domestic credit (% of GDP) of Kazakhstan in 2009 to that in 2011?
Your answer should be compact. 1.4. What is the ratio of the Domestic credit (% of GDP) of Maldives in 2009 to that in 2011?
Keep it short and to the point. 1.25. What is the ratio of the Domestic credit (% of GDP) in Trinidad and Tobago in 2009 to that in 2011?
Keep it short and to the point. 1.23. What is the ratio of the Domestic credit (% of GDP) of Dominica in 2009 to that in 2012?
Make the answer very short. 0.83. What is the ratio of the Domestic credit (% of GDP) of Kazakhstan in 2009 to that in 2012?
Make the answer very short. 1.37. What is the ratio of the Domestic credit (% of GDP) in Maldives in 2009 to that in 2012?
Your answer should be compact. 1.5. What is the ratio of the Domestic credit (% of GDP) of Trinidad and Tobago in 2009 to that in 2012?
Provide a succinct answer. 1.21. What is the ratio of the Domestic credit (% of GDP) in Dominica in 2010 to that in 2011?
Your answer should be compact. 0.96. What is the ratio of the Domestic credit (% of GDP) of Kazakhstan in 2010 to that in 2011?
Provide a short and direct response. 1.09. What is the ratio of the Domestic credit (% of GDP) of Maldives in 2010 to that in 2011?
Provide a succinct answer. 1.14. What is the ratio of the Domestic credit (% of GDP) in Trinidad and Tobago in 2010 to that in 2011?
Provide a succinct answer. 1.11. What is the ratio of the Domestic credit (% of GDP) of Dominica in 2010 to that in 2012?
Offer a terse response. 0.9. What is the ratio of the Domestic credit (% of GDP) in Kazakhstan in 2010 to that in 2012?
Ensure brevity in your answer.  1.07. What is the ratio of the Domestic credit (% of GDP) in Maldives in 2010 to that in 2012?
Provide a short and direct response. 1.36. What is the ratio of the Domestic credit (% of GDP) of Trinidad and Tobago in 2010 to that in 2012?
Keep it short and to the point. 1.09. What is the ratio of the Domestic credit (% of GDP) in Dominica in 2011 to that in 2012?
Give a very brief answer. 0.94. What is the ratio of the Domestic credit (% of GDP) of Kazakhstan in 2011 to that in 2012?
Provide a succinct answer. 0.98. What is the ratio of the Domestic credit (% of GDP) of Maldives in 2011 to that in 2012?
Provide a succinct answer. 1.2. What is the ratio of the Domestic credit (% of GDP) in Trinidad and Tobago in 2011 to that in 2012?
Make the answer very short. 0.98. What is the difference between the highest and the second highest Domestic credit (% of GDP) of Dominica?
Ensure brevity in your answer.  3.65. What is the difference between the highest and the second highest Domestic credit (% of GDP) in Kazakhstan?
Ensure brevity in your answer.  8.67. What is the difference between the highest and the second highest Domestic credit (% of GDP) of Maldives?
Keep it short and to the point. 3.72. What is the difference between the highest and the second highest Domestic credit (% of GDP) in Trinidad and Tobago?
Your answer should be compact. 3.46. What is the difference between the highest and the lowest Domestic credit (% of GDP) in Dominica?
Keep it short and to the point. 10.32. What is the difference between the highest and the lowest Domestic credit (% of GDP) in Kazakhstan?
Provide a succinct answer. 22.95. What is the difference between the highest and the lowest Domestic credit (% of GDP) of Maldives?
Offer a very short reply. 22.32. What is the difference between the highest and the lowest Domestic credit (% of GDP) in Trinidad and Tobago?
Give a very brief answer. 9.24. 